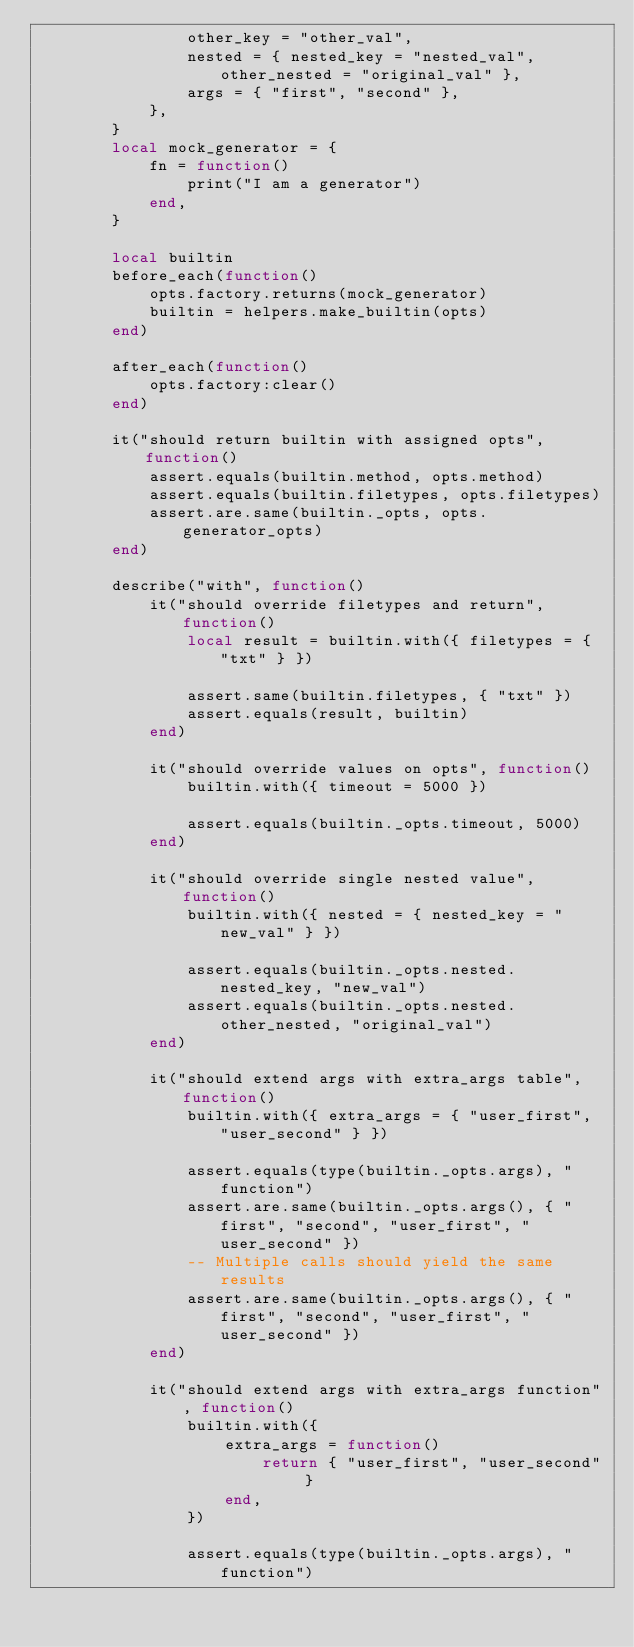<code> <loc_0><loc_0><loc_500><loc_500><_Lua_>                other_key = "other_val",
                nested = { nested_key = "nested_val", other_nested = "original_val" },
                args = { "first", "second" },
            },
        }
        local mock_generator = {
            fn = function()
                print("I am a generator")
            end,
        }

        local builtin
        before_each(function()
            opts.factory.returns(mock_generator)
            builtin = helpers.make_builtin(opts)
        end)

        after_each(function()
            opts.factory:clear()
        end)

        it("should return builtin with assigned opts", function()
            assert.equals(builtin.method, opts.method)
            assert.equals(builtin.filetypes, opts.filetypes)
            assert.are.same(builtin._opts, opts.generator_opts)
        end)

        describe("with", function()
            it("should override filetypes and return", function()
                local result = builtin.with({ filetypes = { "txt" } })

                assert.same(builtin.filetypes, { "txt" })
                assert.equals(result, builtin)
            end)

            it("should override values on opts", function()
                builtin.with({ timeout = 5000 })

                assert.equals(builtin._opts.timeout, 5000)
            end)

            it("should override single nested value", function()
                builtin.with({ nested = { nested_key = "new_val" } })

                assert.equals(builtin._opts.nested.nested_key, "new_val")
                assert.equals(builtin._opts.nested.other_nested, "original_val")
            end)

            it("should extend args with extra_args table", function()
                builtin.with({ extra_args = { "user_first", "user_second" } })

                assert.equals(type(builtin._opts.args), "function")
                assert.are.same(builtin._opts.args(), { "first", "second", "user_first", "user_second" })
                -- Multiple calls should yield the same results
                assert.are.same(builtin._opts.args(), { "first", "second", "user_first", "user_second" })
            end)

            it("should extend args with extra_args function", function()
                builtin.with({
                    extra_args = function()
                        return { "user_first", "user_second" }
                    end,
                })

                assert.equals(type(builtin._opts.args), "function")</code> 